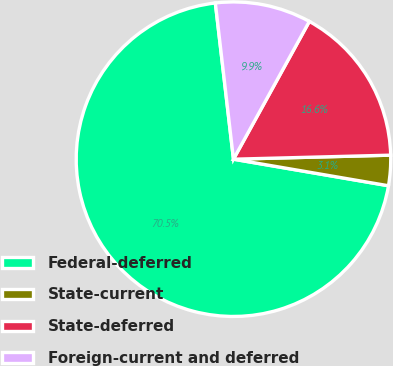Convert chart. <chart><loc_0><loc_0><loc_500><loc_500><pie_chart><fcel>Federal-deferred<fcel>State-current<fcel>State-deferred<fcel>Foreign-current and deferred<nl><fcel>70.46%<fcel>3.11%<fcel>16.58%<fcel>9.85%<nl></chart> 